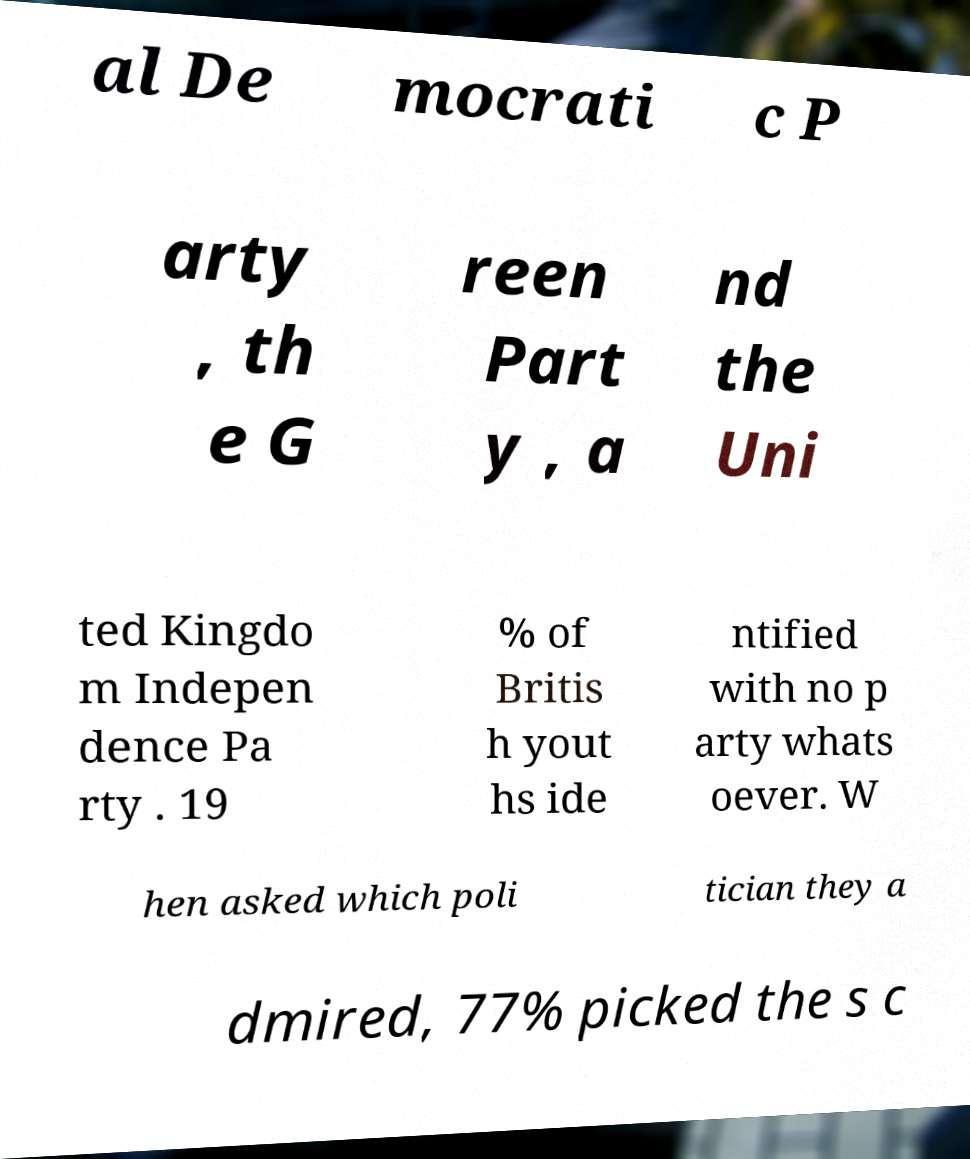What messages or text are displayed in this image? I need them in a readable, typed format. al De mocrati c P arty , th e G reen Part y , a nd the Uni ted Kingdo m Indepen dence Pa rty . 19 % of Britis h yout hs ide ntified with no p arty whats oever. W hen asked which poli tician they a dmired, 77% picked the s c 